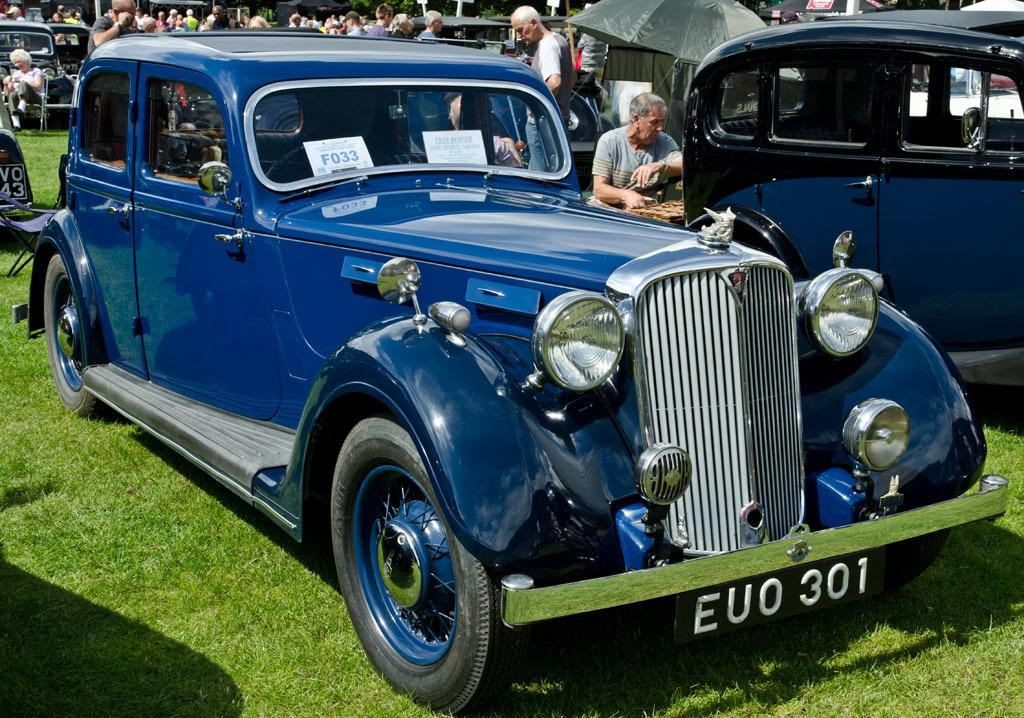What types of vehicles are on the ground in the image? The specific types of vehicles are not mentioned, but there are vehicles on the ground in the image. What can be seen in the background of the image? In the background of the image, there are people, grass, and other unspecified objects. Can you describe the setting of the image? The image shows vehicles on the ground and a background with people, grass, and other objects. How many boys are helping to carry the parcel in the image? There is no parcel or boys present in the image. 